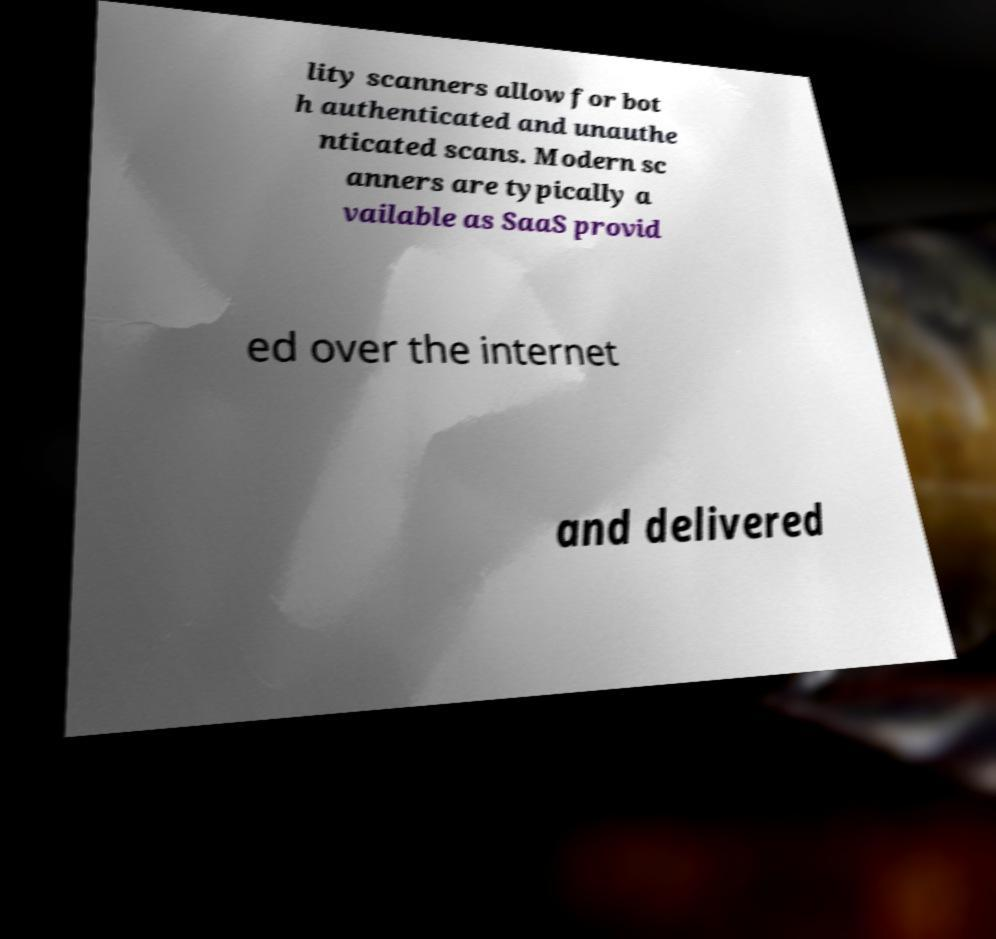There's text embedded in this image that I need extracted. Can you transcribe it verbatim? lity scanners allow for bot h authenticated and unauthe nticated scans. Modern sc anners are typically a vailable as SaaS provid ed over the internet and delivered 